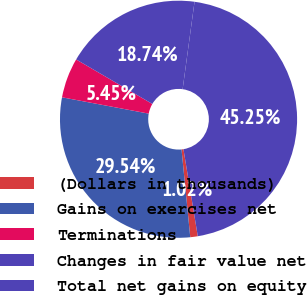Convert chart to OTSL. <chart><loc_0><loc_0><loc_500><loc_500><pie_chart><fcel>(Dollars in thousands)<fcel>Gains on exercises net<fcel>Terminations<fcel>Changes in fair value net<fcel>Total net gains on equity<nl><fcel>1.02%<fcel>29.54%<fcel>5.45%<fcel>18.74%<fcel>45.25%<nl></chart> 